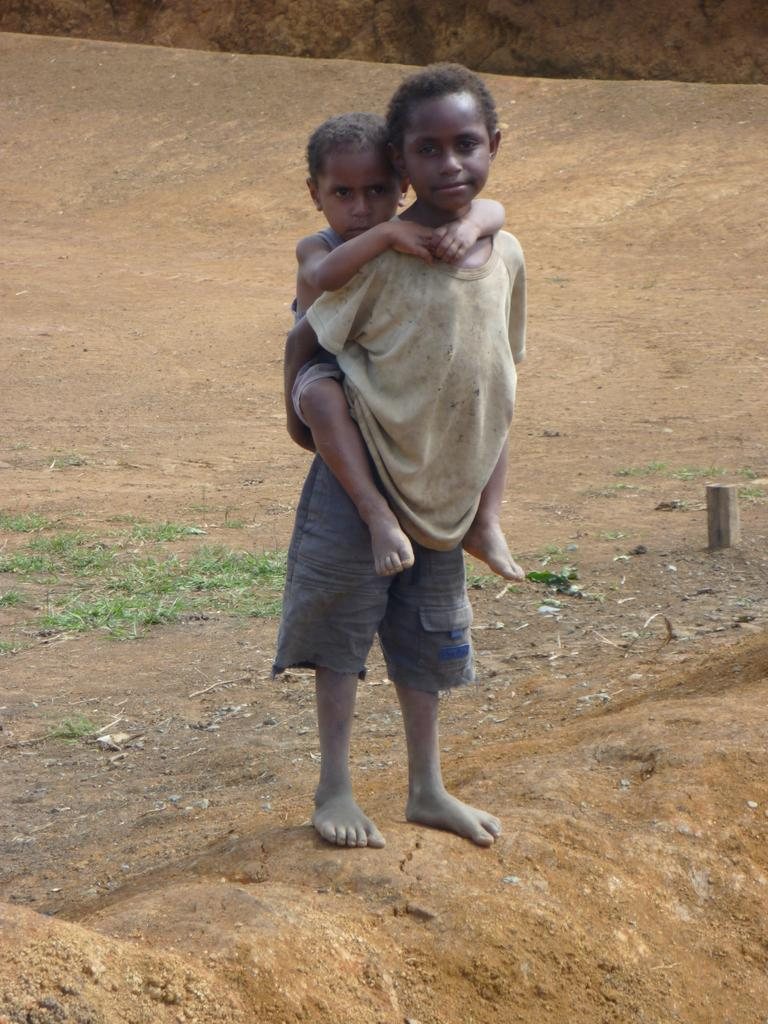Who is the main subject in the image? There is a boy in the image. What is the boy doing in the image? The boy is carrying a child on his back. What else can be seen on the ground in the image? There are objects on the ground in the image. What theory does the goose in the image support? There is no goose present in the image, so it is not possible to discuss any theories it might support. 